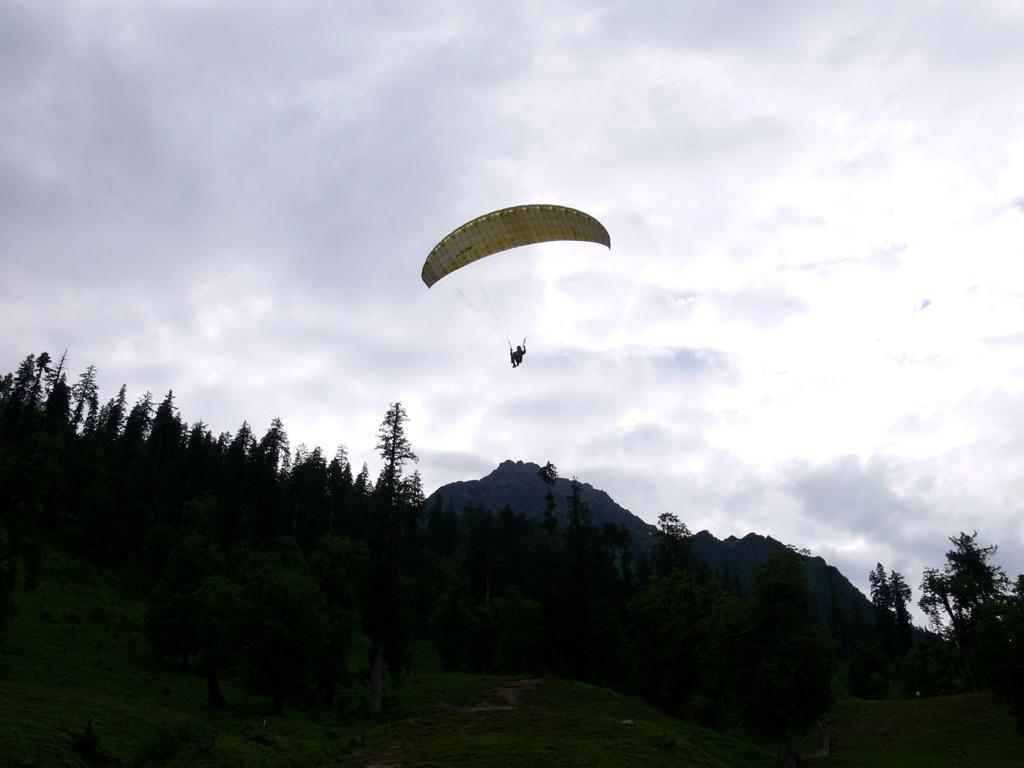Could you give a brief overview of what you see in this image? This picture is clicked outside. In the center we can see a person paragliding in the sky. In the foreground we can see the green grass, plants and trees. In the background we can see the sky which is full of clouds and we can see the objects seems to be the hills. 